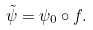<formula> <loc_0><loc_0><loc_500><loc_500>\tilde { \psi } = \psi _ { 0 } \circ f .</formula> 